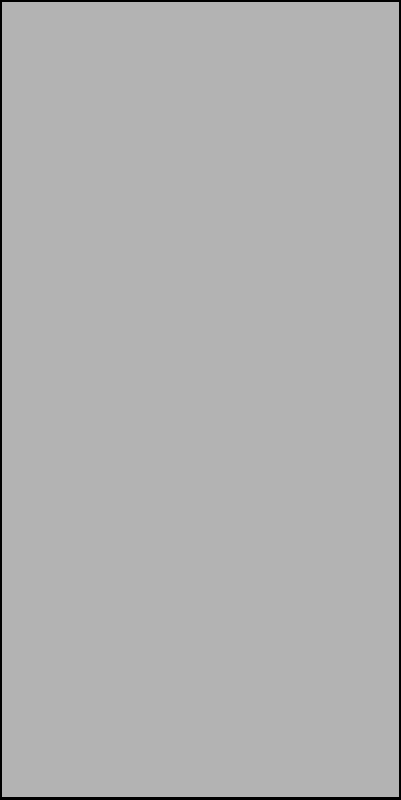A cylindrical soil container with a radius of 20 cm is partially filled with soil. The angle between the soil surface and the horizontal plane is 30°. Calculate the height of the soil column in centimeters. To solve this problem, we'll use trigonometric functions. Let's approach this step-by-step:

1) In the right triangle formed by the soil surface and the container wall, we know:
   - The angle at the center is 30°
   - The adjacent side is the radius of the container, 20 cm

2) We need to find the opposite side, which is the height of the soil column.

3) The trigonometric function that relates the opposite side to the adjacent side in a right triangle is the tangent function.

4) The formula for tangent is:
   $\tan \theta = \frac{\text{opposite}}{\text{adjacent}}$

5) In our case:
   $\tan 30° = \frac{h}{20}$

6) We can rearrange this to solve for $h$:
   $h = 20 \tan 30°$

7) $\tan 30° = \frac{1}{\sqrt{3}} \approx 0.577350269$

8) Therefore:
   $h = 20 \times 0.577350269 = 11.547005383$ cm

9) Rounding to two decimal places:
   $h \approx 11.55$ cm
Answer: 11.55 cm 